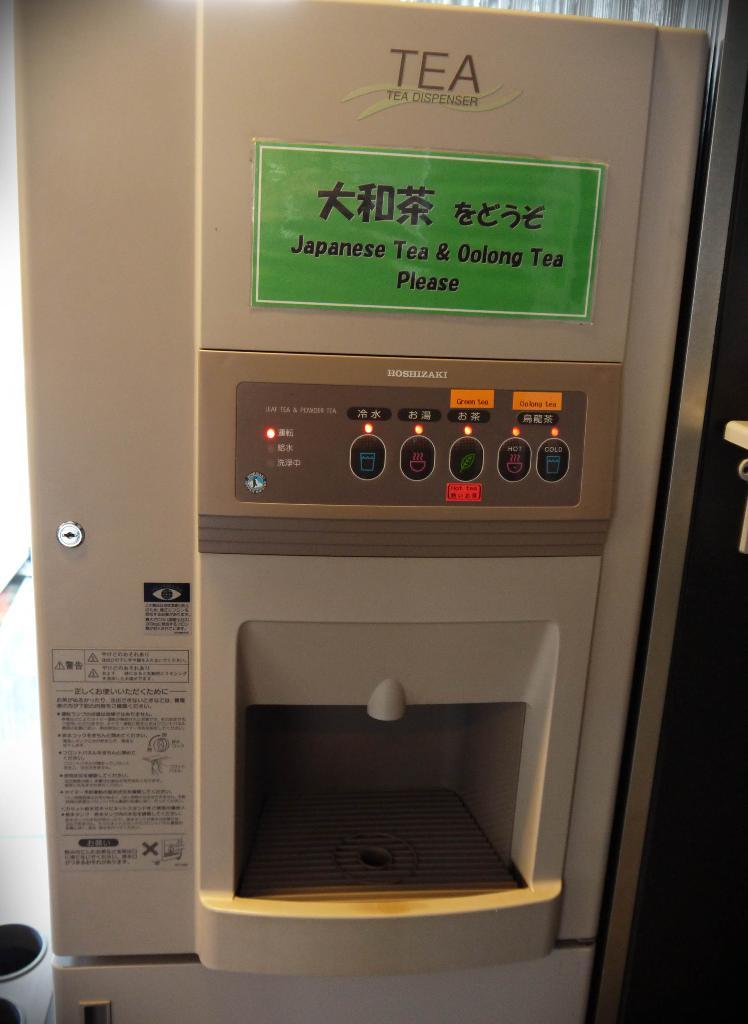<image>
Summarize the visual content of the image. a japanese tea dispenser has a lot of different buttons 